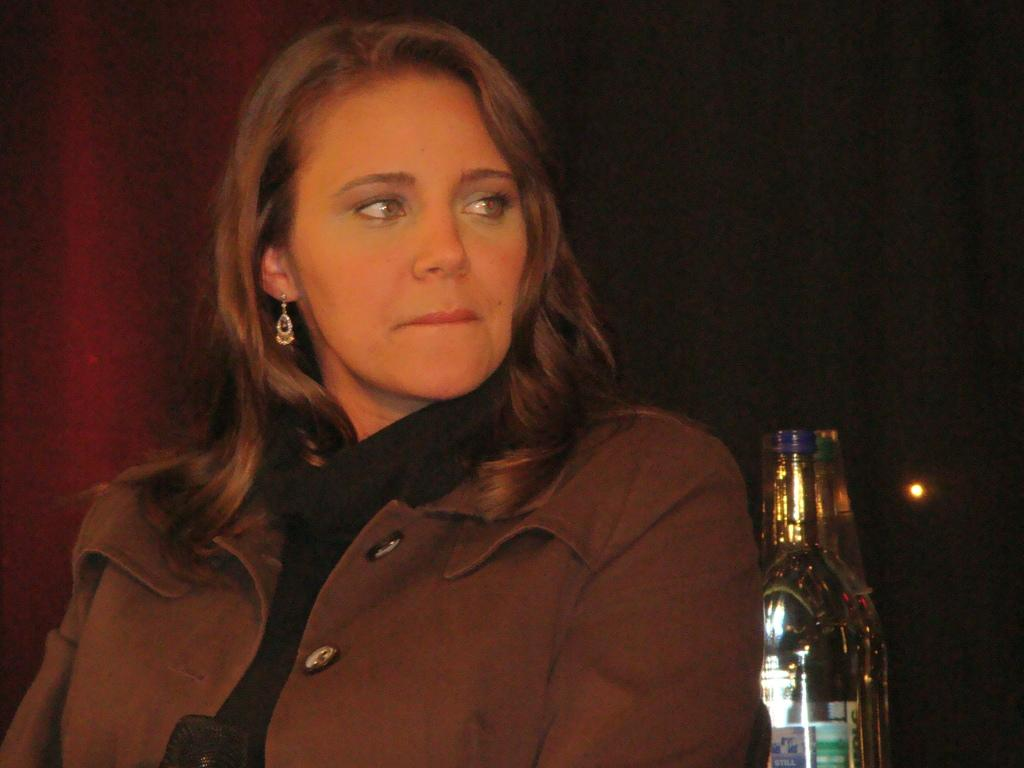Who is present in the image? There is a woman in the image. What is the woman wearing? The woman is wearing a brown jacket. What can be seen in the background of the image? There is a bottle in the background of the image. What type of prison can be seen in the background of the image? There is no prison present in the image; it only features a woman wearing a brown jacket and a bottle in the background. 